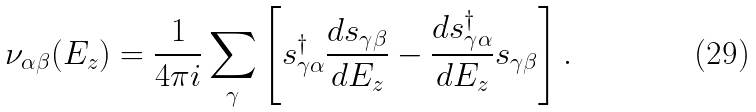Convert formula to latex. <formula><loc_0><loc_0><loc_500><loc_500>\nu _ { \alpha \beta } ( E _ { z } ) = \frac { 1 } { 4 \pi i } \sum _ { \gamma } \left [ s ^ { \dagger } _ { \gamma \alpha } \frac { d s _ { \gamma \beta } } { d E _ { z } } - \frac { d s ^ { \dagger } _ { \gamma \alpha } } { d E _ { z } } s _ { \gamma \beta } \right ] .</formula> 